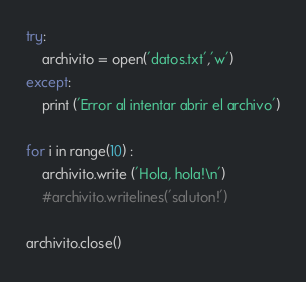Convert code to text. <code><loc_0><loc_0><loc_500><loc_500><_Python_>try:
    archivito = open('datos.txt','w')
except:
    print ('Error al intentar abrir el archivo')

for i in range(10) :
    archivito.write ('Hola, hola!\n')
    #archivito.writelines('saluton!')

archivito.close()</code> 